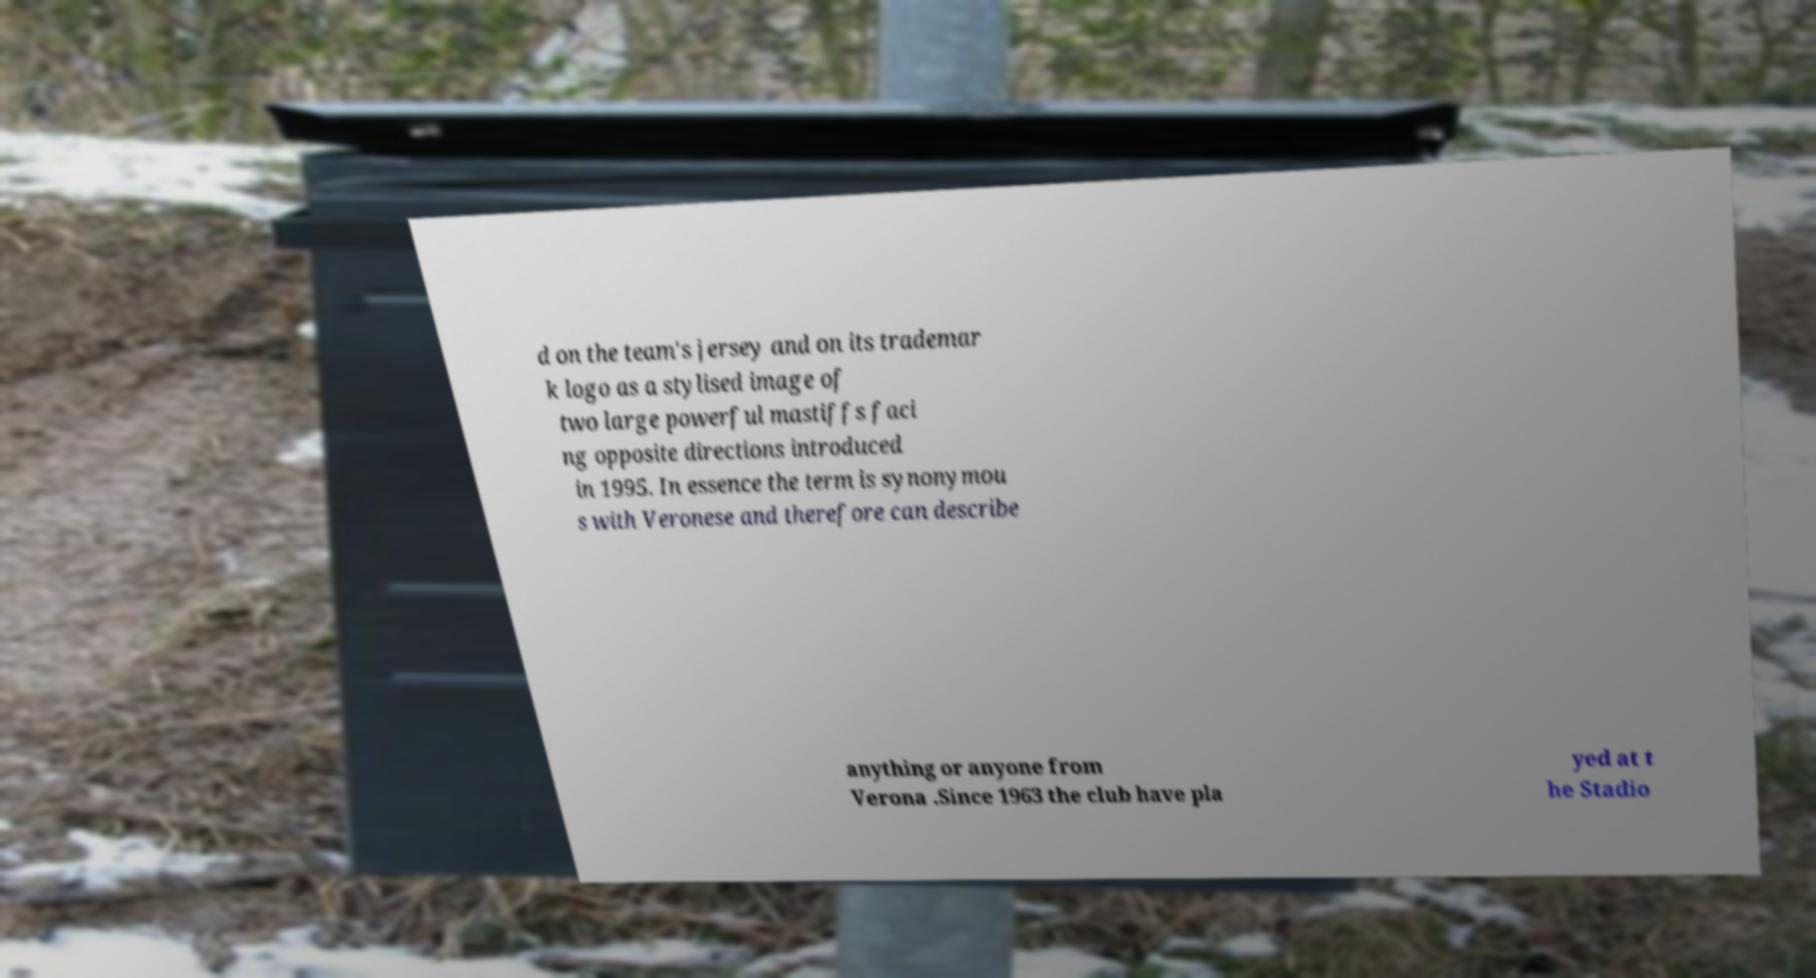What messages or text are displayed in this image? I need them in a readable, typed format. d on the team's jersey and on its trademar k logo as a stylised image of two large powerful mastiffs faci ng opposite directions introduced in 1995. In essence the term is synonymou s with Veronese and therefore can describe anything or anyone from Verona .Since 1963 the club have pla yed at t he Stadio 